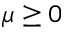Convert formula to latex. <formula><loc_0><loc_0><loc_500><loc_500>\mu \geq 0</formula> 